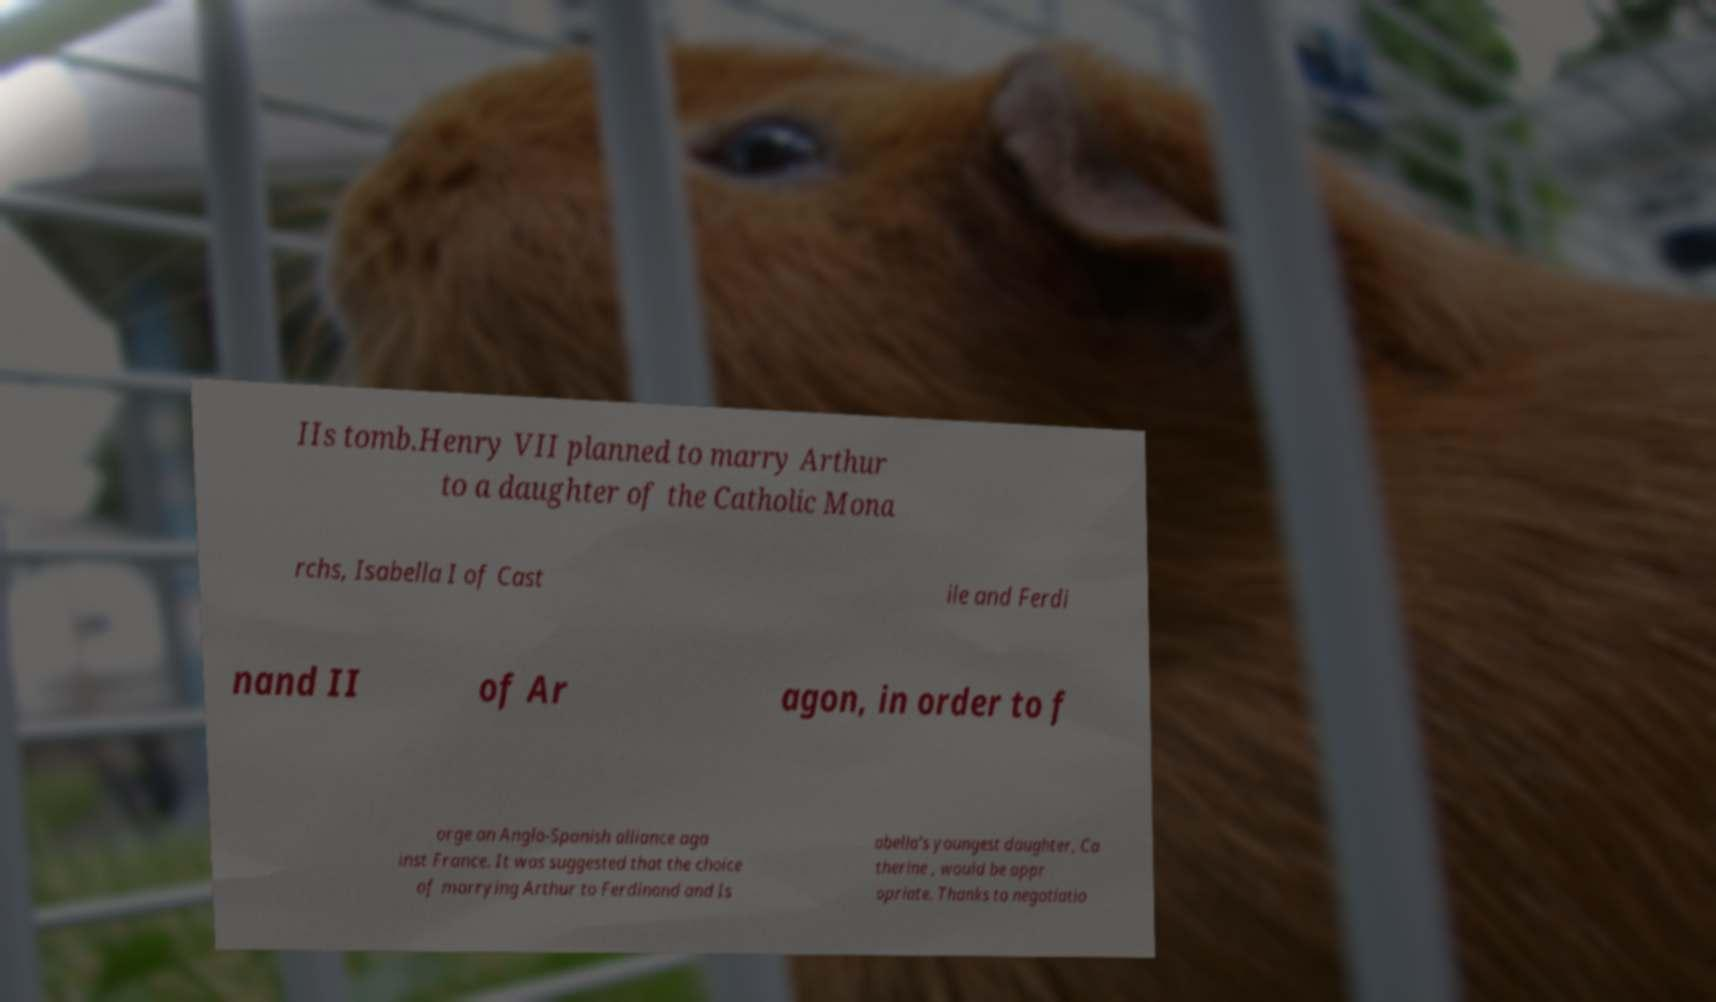There's text embedded in this image that I need extracted. Can you transcribe it verbatim? IIs tomb.Henry VII planned to marry Arthur to a daughter of the Catholic Mona rchs, Isabella I of Cast ile and Ferdi nand II of Ar agon, in order to f orge an Anglo-Spanish alliance aga inst France. It was suggested that the choice of marrying Arthur to Ferdinand and Is abella's youngest daughter, Ca therine , would be appr opriate. Thanks to negotiatio 